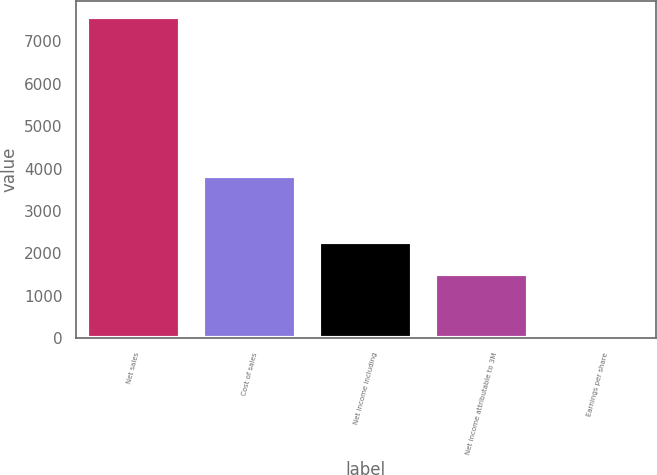<chart> <loc_0><loc_0><loc_500><loc_500><bar_chart><fcel>Net sales<fcel>Cost of sales<fcel>Net income including<fcel>Net income attributable to 3M<fcel>Earnings per share<nl><fcel>7578<fcel>3821<fcel>2274.7<fcel>1517.09<fcel>1.85<nl></chart> 